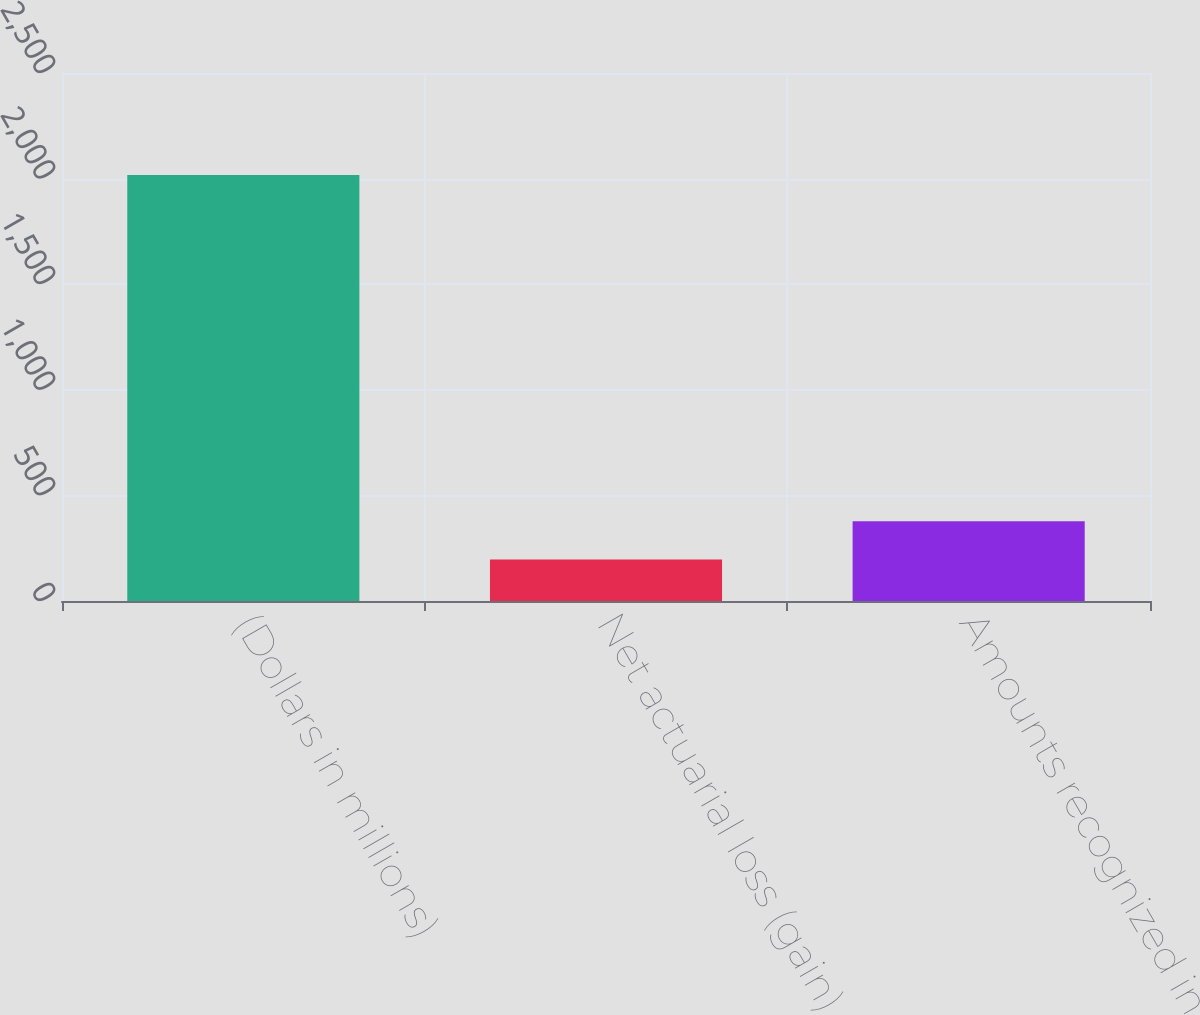Convert chart to OTSL. <chart><loc_0><loc_0><loc_500><loc_500><bar_chart><fcel>(Dollars in millions)<fcel>Net actuarial loss (gain)<fcel>Amounts recognized in<nl><fcel>2017<fcel>196<fcel>378.1<nl></chart> 